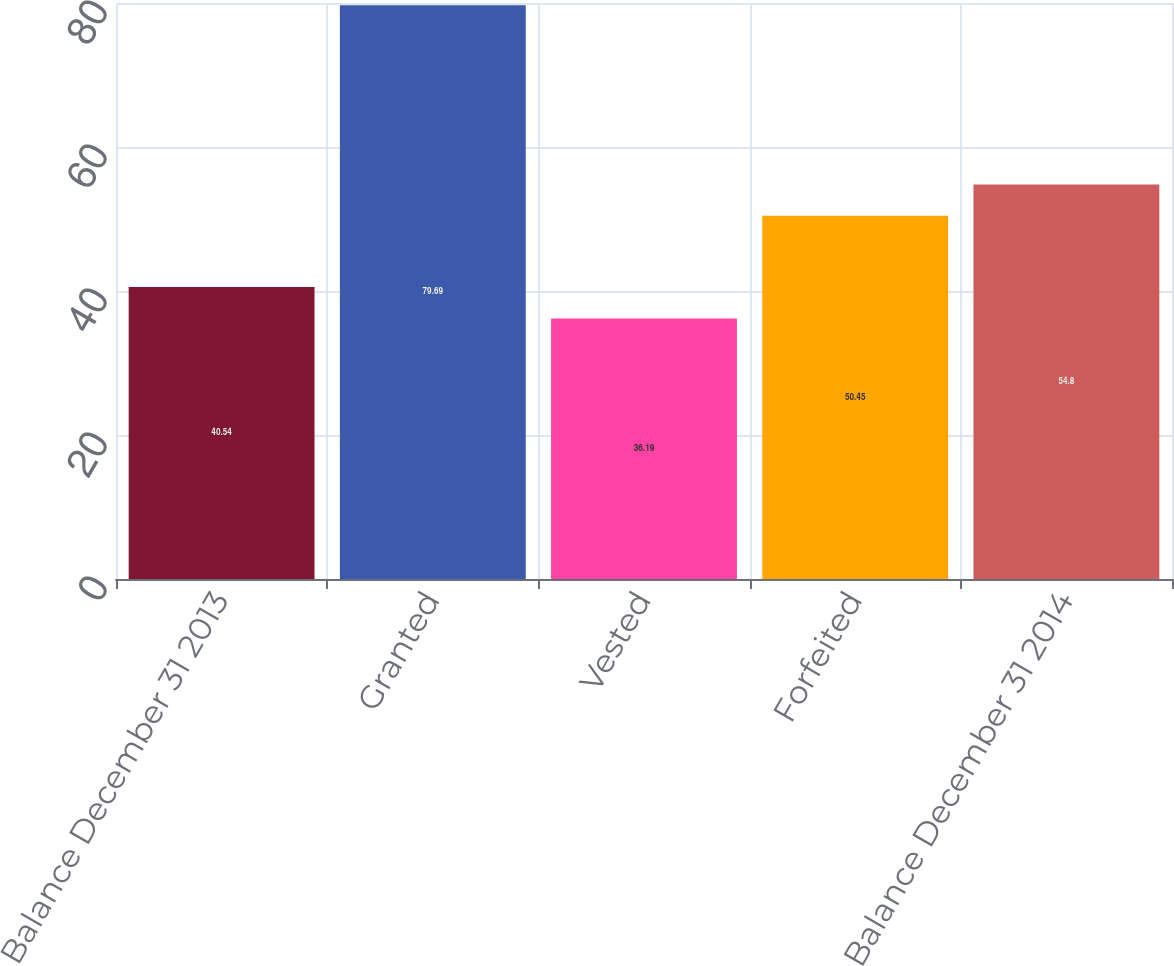Convert chart to OTSL. <chart><loc_0><loc_0><loc_500><loc_500><bar_chart><fcel>Balance December 31 2013<fcel>Granted<fcel>Vested<fcel>Forfeited<fcel>Balance December 31 2014<nl><fcel>40.54<fcel>79.69<fcel>36.19<fcel>50.45<fcel>54.8<nl></chart> 